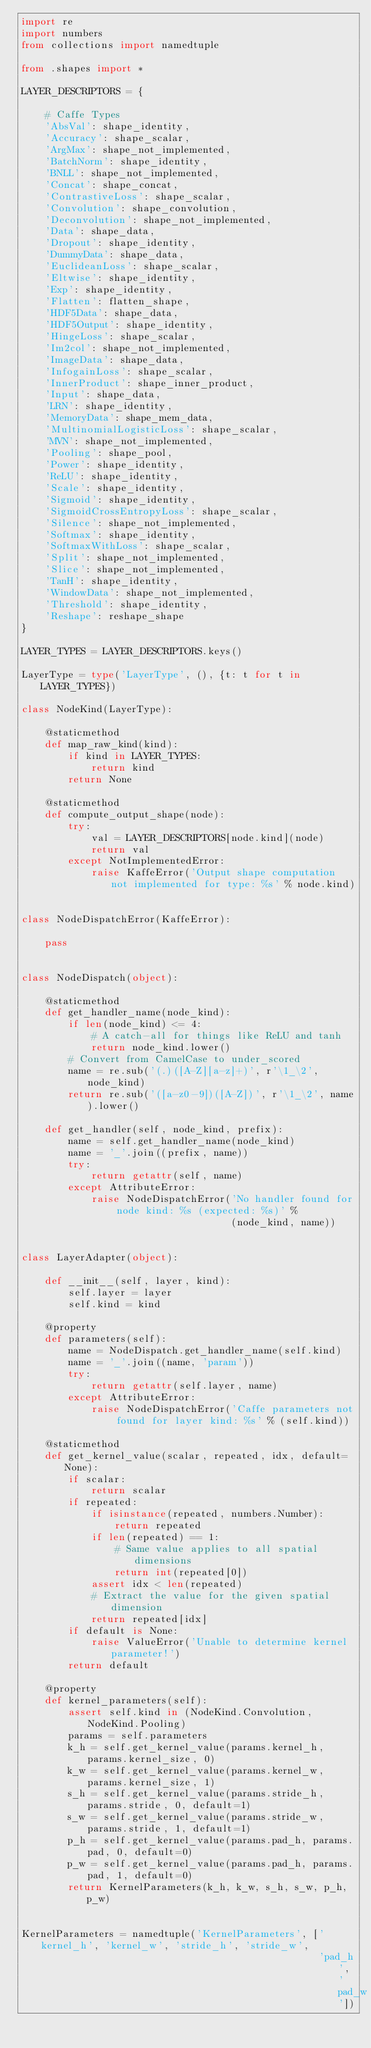<code> <loc_0><loc_0><loc_500><loc_500><_Python_>import re
import numbers
from collections import namedtuple

from .shapes import *

LAYER_DESCRIPTORS = {

    # Caffe Types
    'AbsVal': shape_identity,
    'Accuracy': shape_scalar,
    'ArgMax': shape_not_implemented,
    'BatchNorm': shape_identity,
    'BNLL': shape_not_implemented,
    'Concat': shape_concat,
    'ContrastiveLoss': shape_scalar,
    'Convolution': shape_convolution,
    'Deconvolution': shape_not_implemented,
    'Data': shape_data,
    'Dropout': shape_identity,
    'DummyData': shape_data,
    'EuclideanLoss': shape_scalar,
    'Eltwise': shape_identity,
    'Exp': shape_identity,
    'Flatten': flatten_shape,
    'HDF5Data': shape_data,
    'HDF5Output': shape_identity,
    'HingeLoss': shape_scalar,
    'Im2col': shape_not_implemented,
    'ImageData': shape_data,
    'InfogainLoss': shape_scalar,
    'InnerProduct': shape_inner_product,
    'Input': shape_data,
    'LRN': shape_identity,
    'MemoryData': shape_mem_data,
    'MultinomialLogisticLoss': shape_scalar,
    'MVN': shape_not_implemented,
    'Pooling': shape_pool,
    'Power': shape_identity,
    'ReLU': shape_identity,
    'Scale': shape_identity,
    'Sigmoid': shape_identity,
    'SigmoidCrossEntropyLoss': shape_scalar,
    'Silence': shape_not_implemented,
    'Softmax': shape_identity,
    'SoftmaxWithLoss': shape_scalar,
    'Split': shape_not_implemented,
    'Slice': shape_not_implemented,
    'TanH': shape_identity,
    'WindowData': shape_not_implemented,
    'Threshold': shape_identity,
    'Reshape': reshape_shape
}

LAYER_TYPES = LAYER_DESCRIPTORS.keys()

LayerType = type('LayerType', (), {t: t for t in LAYER_TYPES})

class NodeKind(LayerType):

    @staticmethod
    def map_raw_kind(kind):
        if kind in LAYER_TYPES:
            return kind
        return None

    @staticmethod
    def compute_output_shape(node):
        try:
            val = LAYER_DESCRIPTORS[node.kind](node)
            return val
        except NotImplementedError:
            raise KaffeError('Output shape computation not implemented for type: %s' % node.kind)


class NodeDispatchError(KaffeError):

    pass


class NodeDispatch(object):

    @staticmethod
    def get_handler_name(node_kind):
        if len(node_kind) <= 4:
            # A catch-all for things like ReLU and tanh
            return node_kind.lower()
        # Convert from CamelCase to under_scored
        name = re.sub('(.)([A-Z][a-z]+)', r'\1_\2', node_kind)
        return re.sub('([a-z0-9])([A-Z])', r'\1_\2', name).lower()

    def get_handler(self, node_kind, prefix):
        name = self.get_handler_name(node_kind)
        name = '_'.join((prefix, name))
        try:
            return getattr(self, name)
        except AttributeError:
            raise NodeDispatchError('No handler found for node kind: %s (expected: %s)' %
                                    (node_kind, name))


class LayerAdapter(object):

    def __init__(self, layer, kind):
        self.layer = layer
        self.kind = kind

    @property
    def parameters(self):
        name = NodeDispatch.get_handler_name(self.kind)
        name = '_'.join((name, 'param'))
        try:
            return getattr(self.layer, name)
        except AttributeError:
            raise NodeDispatchError('Caffe parameters not found for layer kind: %s' % (self.kind))

    @staticmethod
    def get_kernel_value(scalar, repeated, idx, default=None):
        if scalar:
            return scalar
        if repeated:
            if isinstance(repeated, numbers.Number):
                return repeated
            if len(repeated) == 1:
                # Same value applies to all spatial dimensions
                return int(repeated[0])
            assert idx < len(repeated)
            # Extract the value for the given spatial dimension
            return repeated[idx]
        if default is None:
            raise ValueError('Unable to determine kernel parameter!')
        return default

    @property
    def kernel_parameters(self):
        assert self.kind in (NodeKind.Convolution, NodeKind.Pooling)
        params = self.parameters
        k_h = self.get_kernel_value(params.kernel_h, params.kernel_size, 0)
        k_w = self.get_kernel_value(params.kernel_w, params.kernel_size, 1)
        s_h = self.get_kernel_value(params.stride_h, params.stride, 0, default=1)
        s_w = self.get_kernel_value(params.stride_w, params.stride, 1, default=1)
        p_h = self.get_kernel_value(params.pad_h, params.pad, 0, default=0)
        p_w = self.get_kernel_value(params.pad_h, params.pad, 1, default=0)
        return KernelParameters(k_h, k_w, s_h, s_w, p_h, p_w)


KernelParameters = namedtuple('KernelParameters', ['kernel_h', 'kernel_w', 'stride_h', 'stride_w',
                                                   'pad_h', 'pad_w'])
</code> 